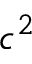Convert formula to latex. <formula><loc_0><loc_0><loc_500><loc_500>c ^ { 2 }</formula> 